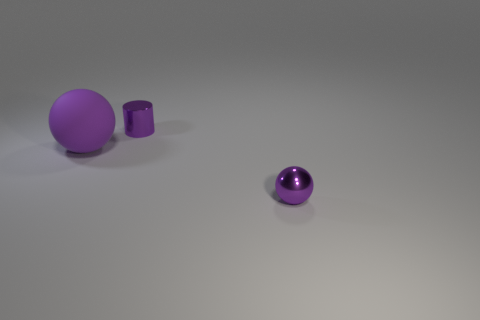How would you describe the surface the objects are placed on? The objects are situated on a flat, smooth surface with a subtle gradient that spans from light to dark. The surface has a soft reflection which suggests it might be lightly textured or made of a matte material. 